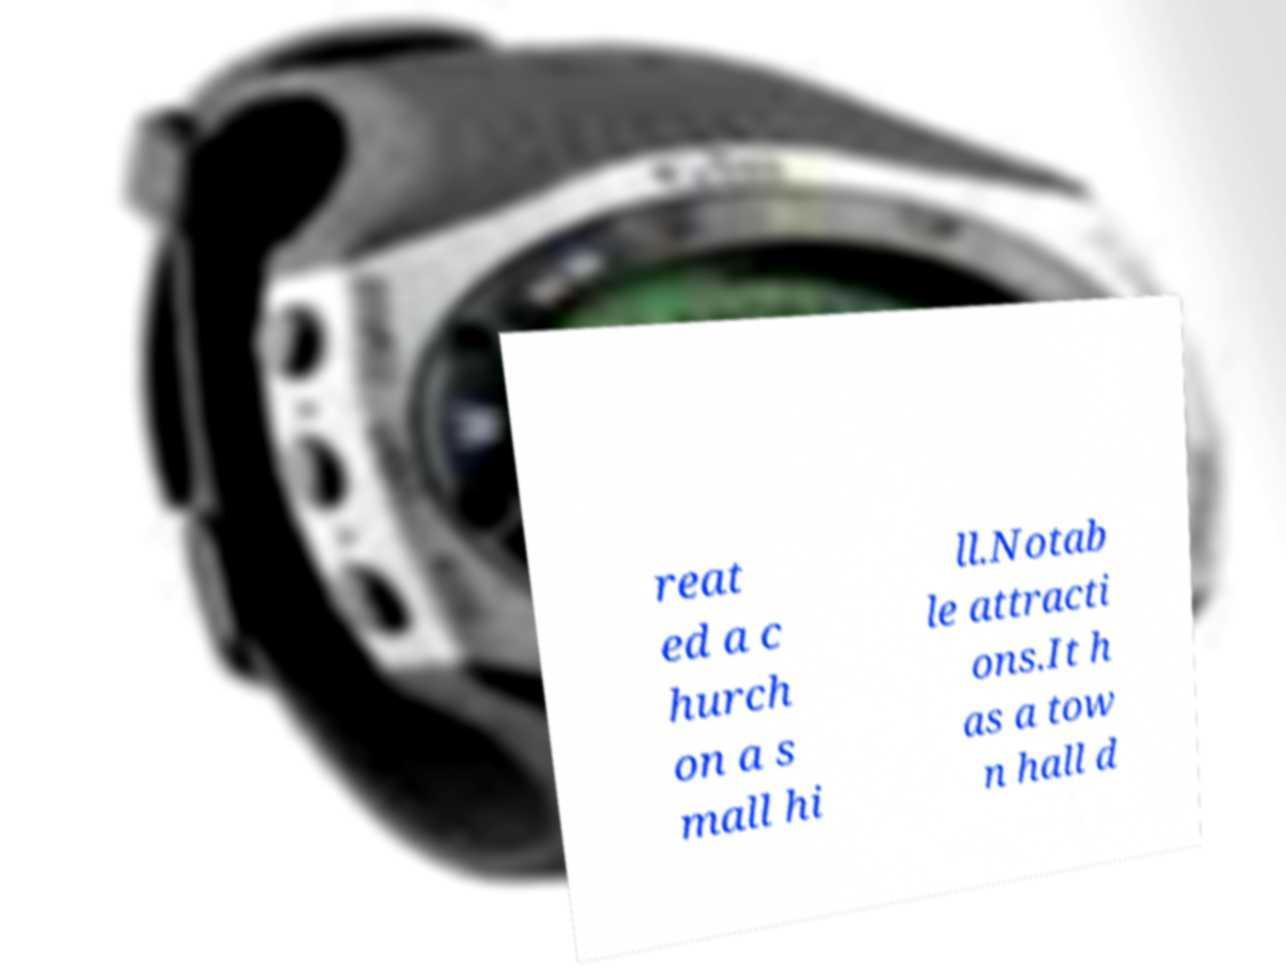What messages or text are displayed in this image? I need them in a readable, typed format. reat ed a c hurch on a s mall hi ll.Notab le attracti ons.It h as a tow n hall d 